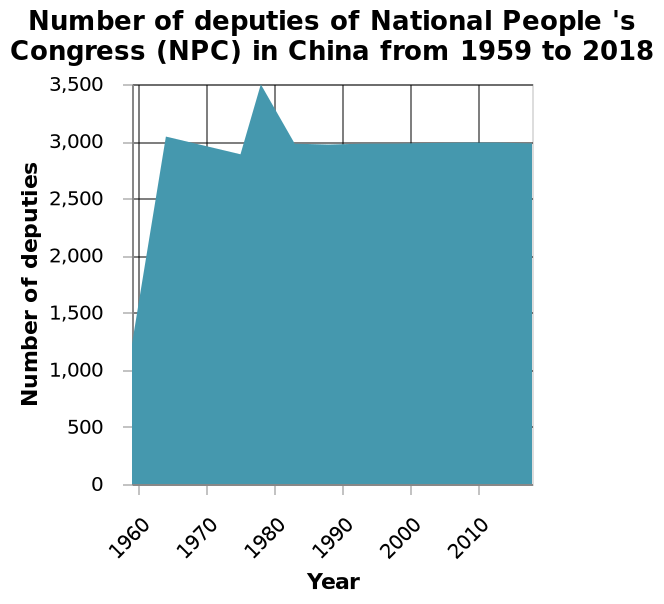<image>
Was the number of deputies in duty higher in the 1970's compared to other decades?  The description does not provide information on the number of deputies in duty compared to other decades. When was the highest number of deputies in duty?  The highest number of deputies in duty was towards the end of the 1970's. How many deputies were on duty during the 1970's?  The description does not provide the exact number of deputies on duty during the 1970's. 